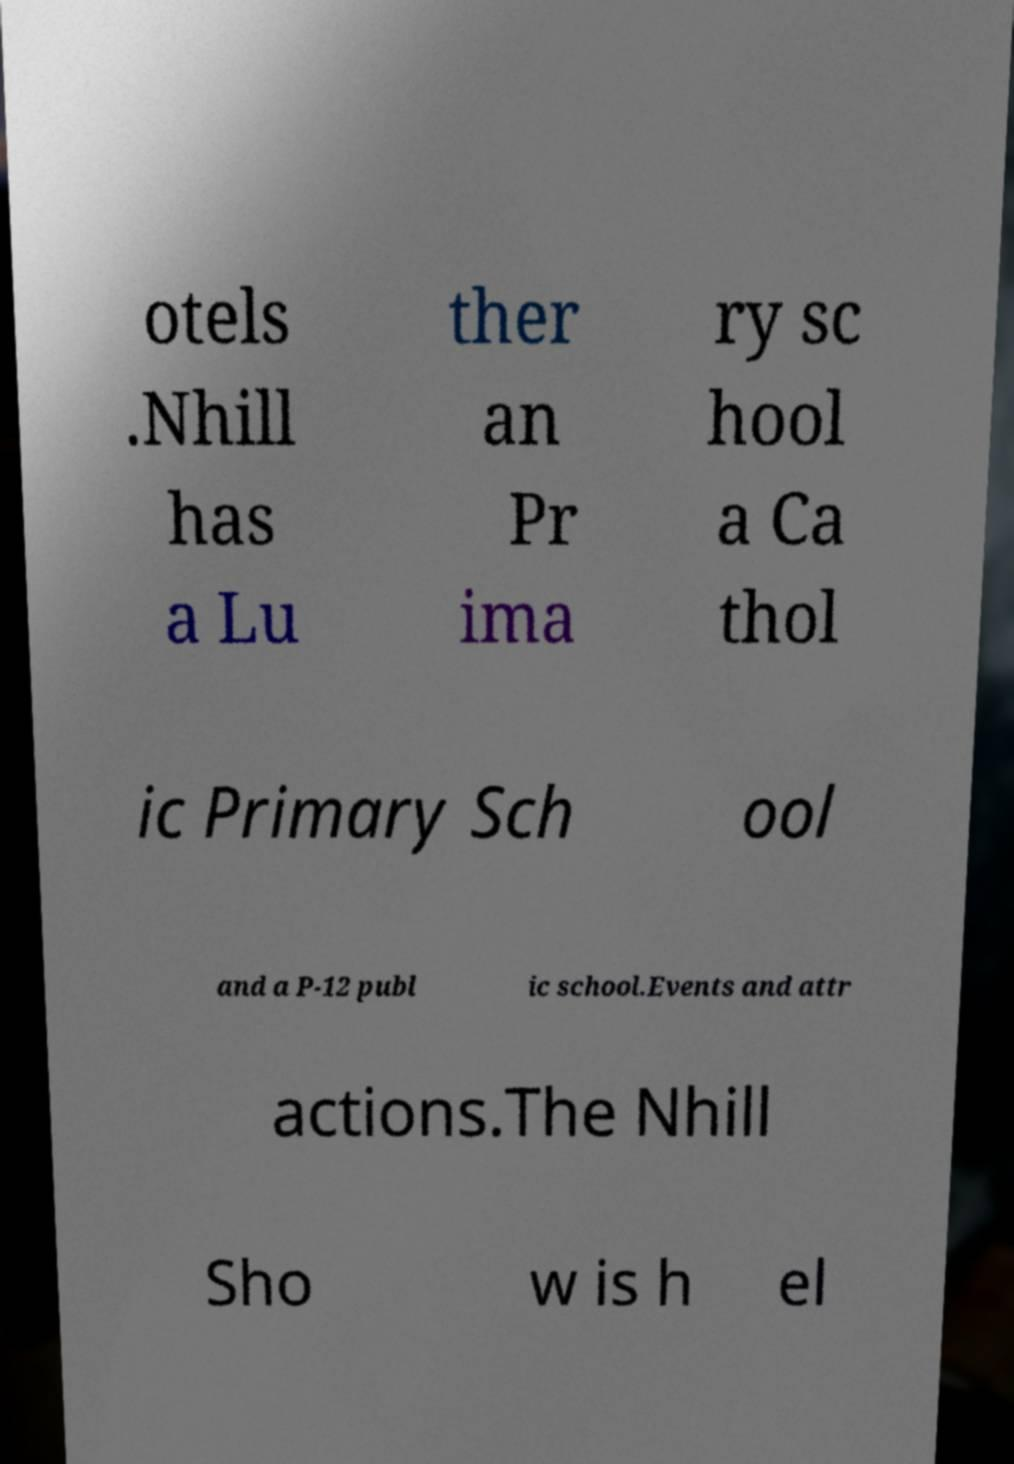Could you assist in decoding the text presented in this image and type it out clearly? otels .Nhill has a Lu ther an Pr ima ry sc hool a Ca thol ic Primary Sch ool and a P-12 publ ic school.Events and attr actions.The Nhill Sho w is h el 